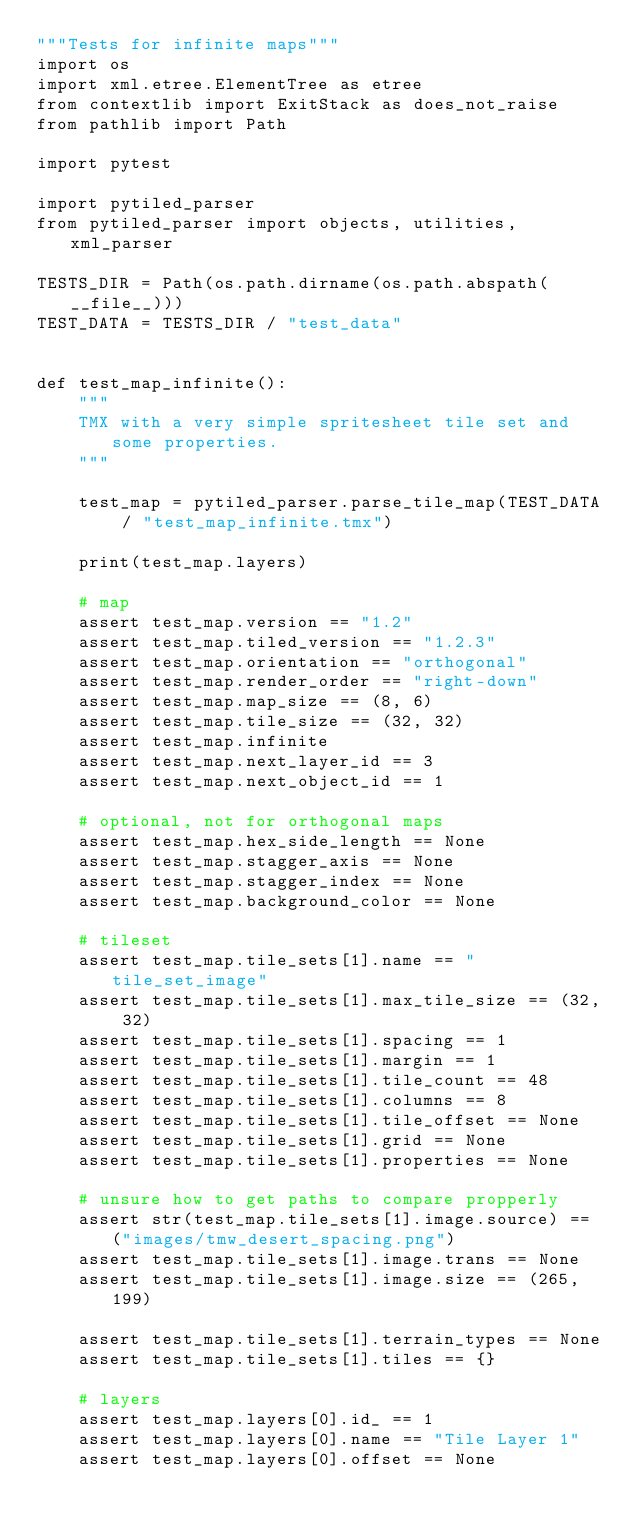Convert code to text. <code><loc_0><loc_0><loc_500><loc_500><_Python_>"""Tests for infinite maps"""
import os
import xml.etree.ElementTree as etree
from contextlib import ExitStack as does_not_raise
from pathlib import Path

import pytest

import pytiled_parser
from pytiled_parser import objects, utilities, xml_parser

TESTS_DIR = Path(os.path.dirname(os.path.abspath(__file__)))
TEST_DATA = TESTS_DIR / "test_data"


def test_map_infinite():
    """
    TMX with a very simple spritesheet tile set and some properties.
    """

    test_map = pytiled_parser.parse_tile_map(TEST_DATA / "test_map_infinite.tmx")

    print(test_map.layers)

    # map
    assert test_map.version == "1.2"
    assert test_map.tiled_version == "1.2.3"
    assert test_map.orientation == "orthogonal"
    assert test_map.render_order == "right-down"
    assert test_map.map_size == (8, 6)
    assert test_map.tile_size == (32, 32)
    assert test_map.infinite
    assert test_map.next_layer_id == 3
    assert test_map.next_object_id == 1

    # optional, not for orthogonal maps
    assert test_map.hex_side_length == None
    assert test_map.stagger_axis == None
    assert test_map.stagger_index == None
    assert test_map.background_color == None

    # tileset
    assert test_map.tile_sets[1].name == "tile_set_image"
    assert test_map.tile_sets[1].max_tile_size == (32, 32)
    assert test_map.tile_sets[1].spacing == 1
    assert test_map.tile_sets[1].margin == 1
    assert test_map.tile_sets[1].tile_count == 48
    assert test_map.tile_sets[1].columns == 8
    assert test_map.tile_sets[1].tile_offset == None
    assert test_map.tile_sets[1].grid == None
    assert test_map.tile_sets[1].properties == None

    # unsure how to get paths to compare propperly
    assert str(test_map.tile_sets[1].image.source) == ("images/tmw_desert_spacing.png")
    assert test_map.tile_sets[1].image.trans == None
    assert test_map.tile_sets[1].image.size == (265, 199)

    assert test_map.tile_sets[1].terrain_types == None
    assert test_map.tile_sets[1].tiles == {}

    # layers
    assert test_map.layers[0].id_ == 1
    assert test_map.layers[0].name == "Tile Layer 1"
    assert test_map.layers[0].offset == None</code> 